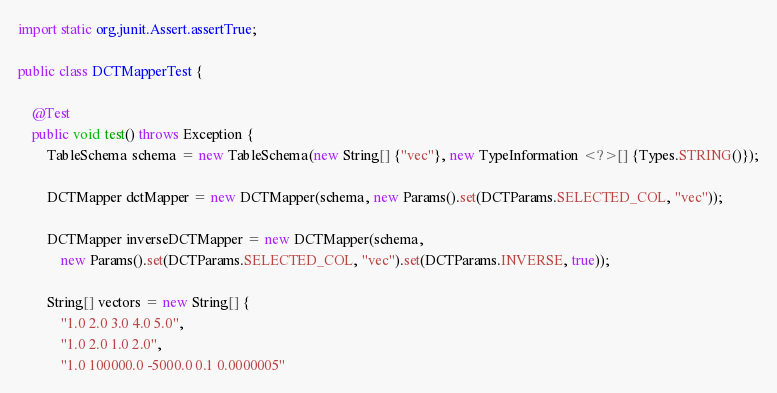Convert code to text. <code><loc_0><loc_0><loc_500><loc_500><_Java_>import static org.junit.Assert.assertTrue;

public class DCTMapperTest {

	@Test
	public void test() throws Exception {
		TableSchema schema = new TableSchema(new String[] {"vec"}, new TypeInformation <?>[] {Types.STRING()});

		DCTMapper dctMapper = new DCTMapper(schema, new Params().set(DCTParams.SELECTED_COL, "vec"));

		DCTMapper inverseDCTMapper = new DCTMapper(schema,
			new Params().set(DCTParams.SELECTED_COL, "vec").set(DCTParams.INVERSE, true));

		String[] vectors = new String[] {
			"1.0 2.0 3.0 4.0 5.0",
			"1.0 2.0 1.0 2.0",
			"1.0 100000.0 -5000.0 0.1 0.0000005"</code> 